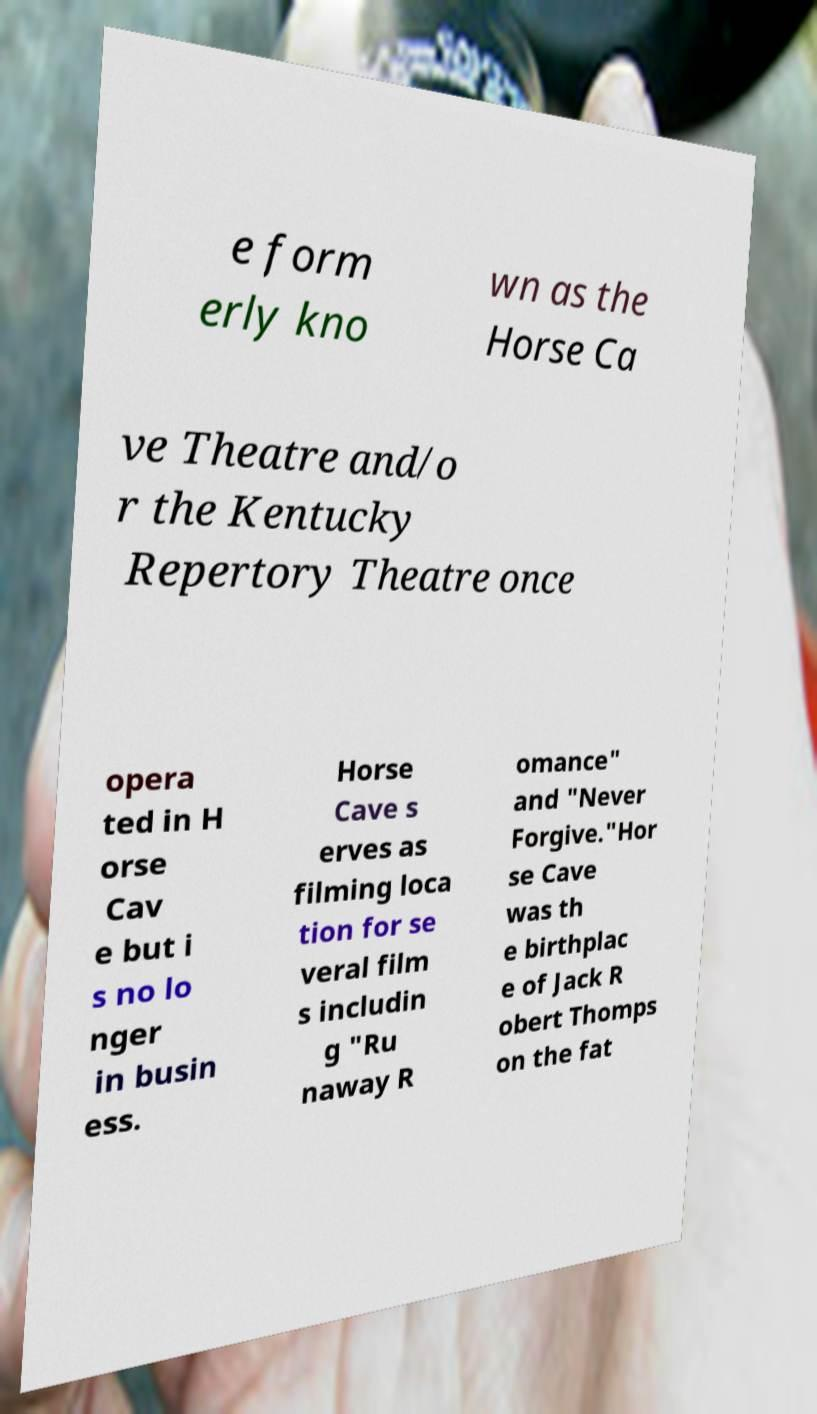What messages or text are displayed in this image? I need them in a readable, typed format. e form erly kno wn as the Horse Ca ve Theatre and/o r the Kentucky Repertory Theatre once opera ted in H orse Cav e but i s no lo nger in busin ess. Horse Cave s erves as filming loca tion for se veral film s includin g "Ru naway R omance" and "Never Forgive."Hor se Cave was th e birthplac e of Jack R obert Thomps on the fat 